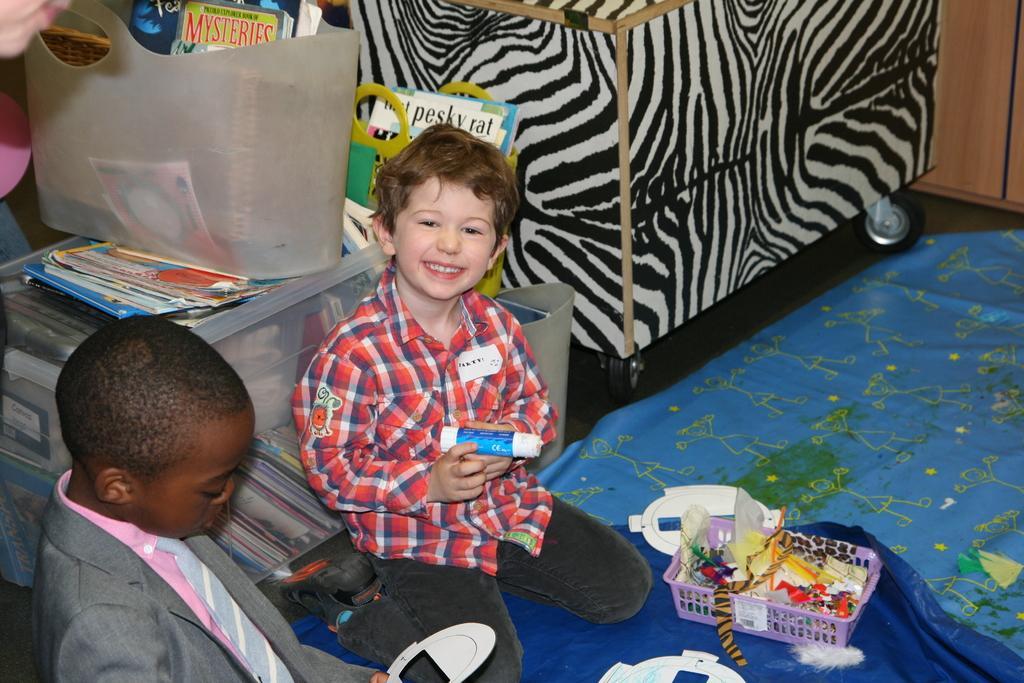Can you describe this image briefly? In this picture there is a small boy wearing red color t-shirt is sitting in the room, smiling and giving a pose into the camera. Beside there is a African boy sitting and looking into the toys. Behind there is a black and white color sofa and plastic basket full of story books. 